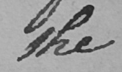What is written in this line of handwriting? the 